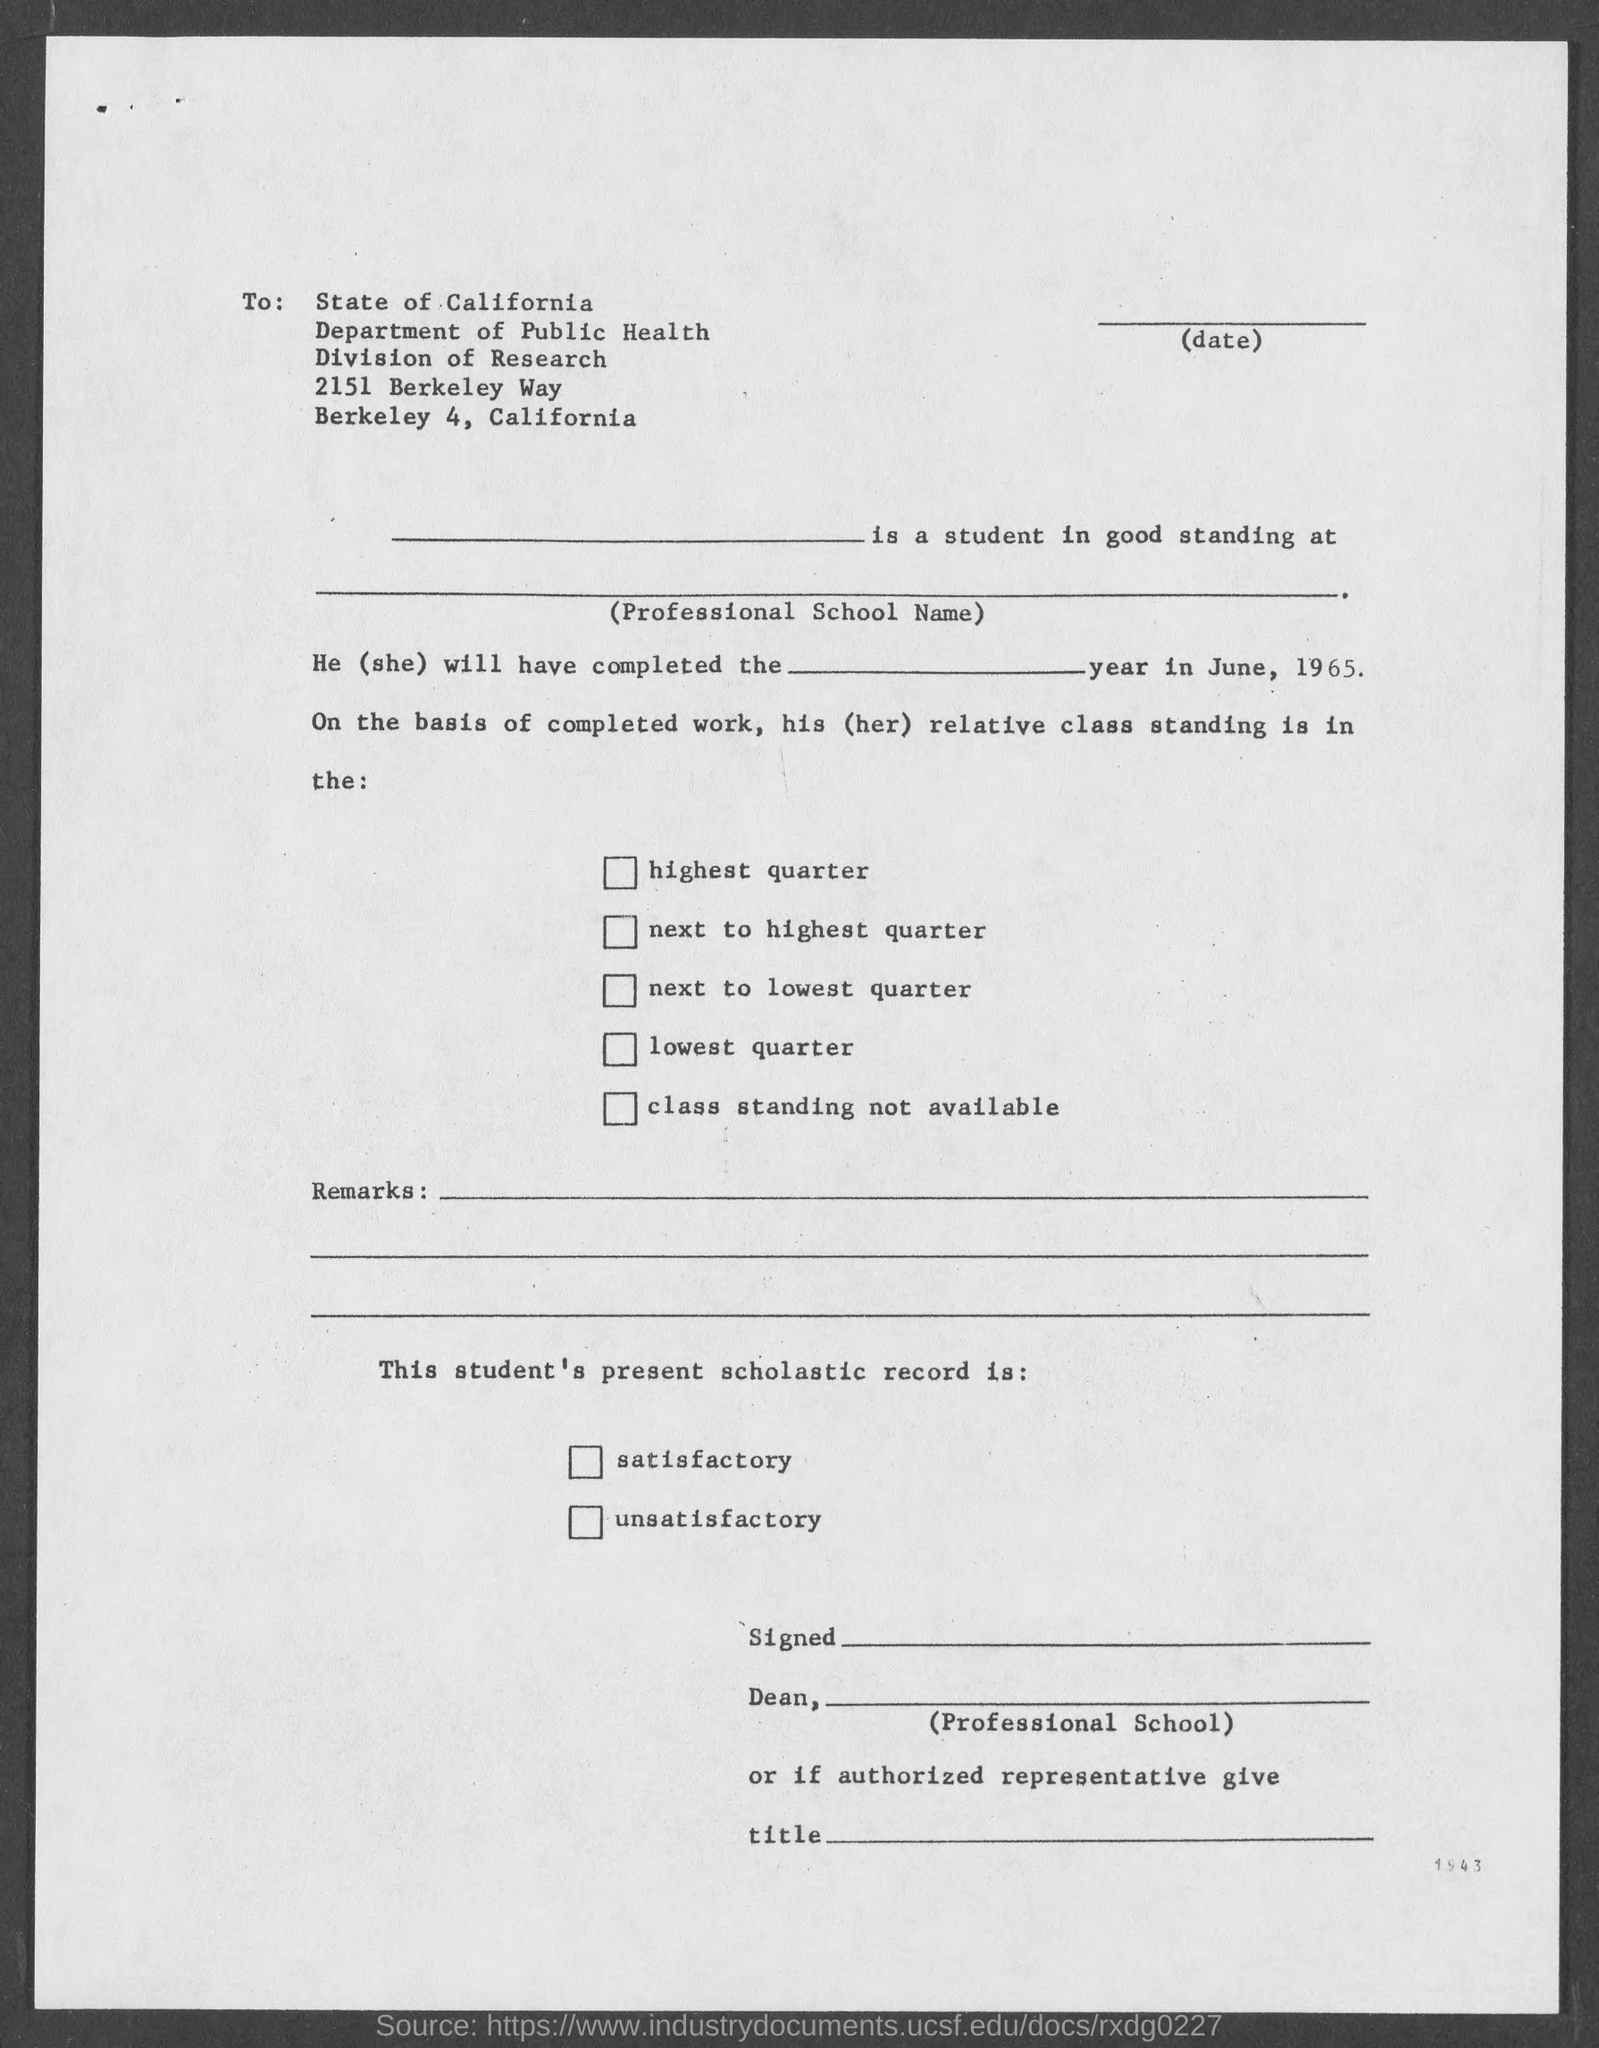Outline some significant characteristics in this image. The division mentioned on the given page is research division. The letter was sent to the state of California. The department mentioned in the given form is the Department of Public Health. 